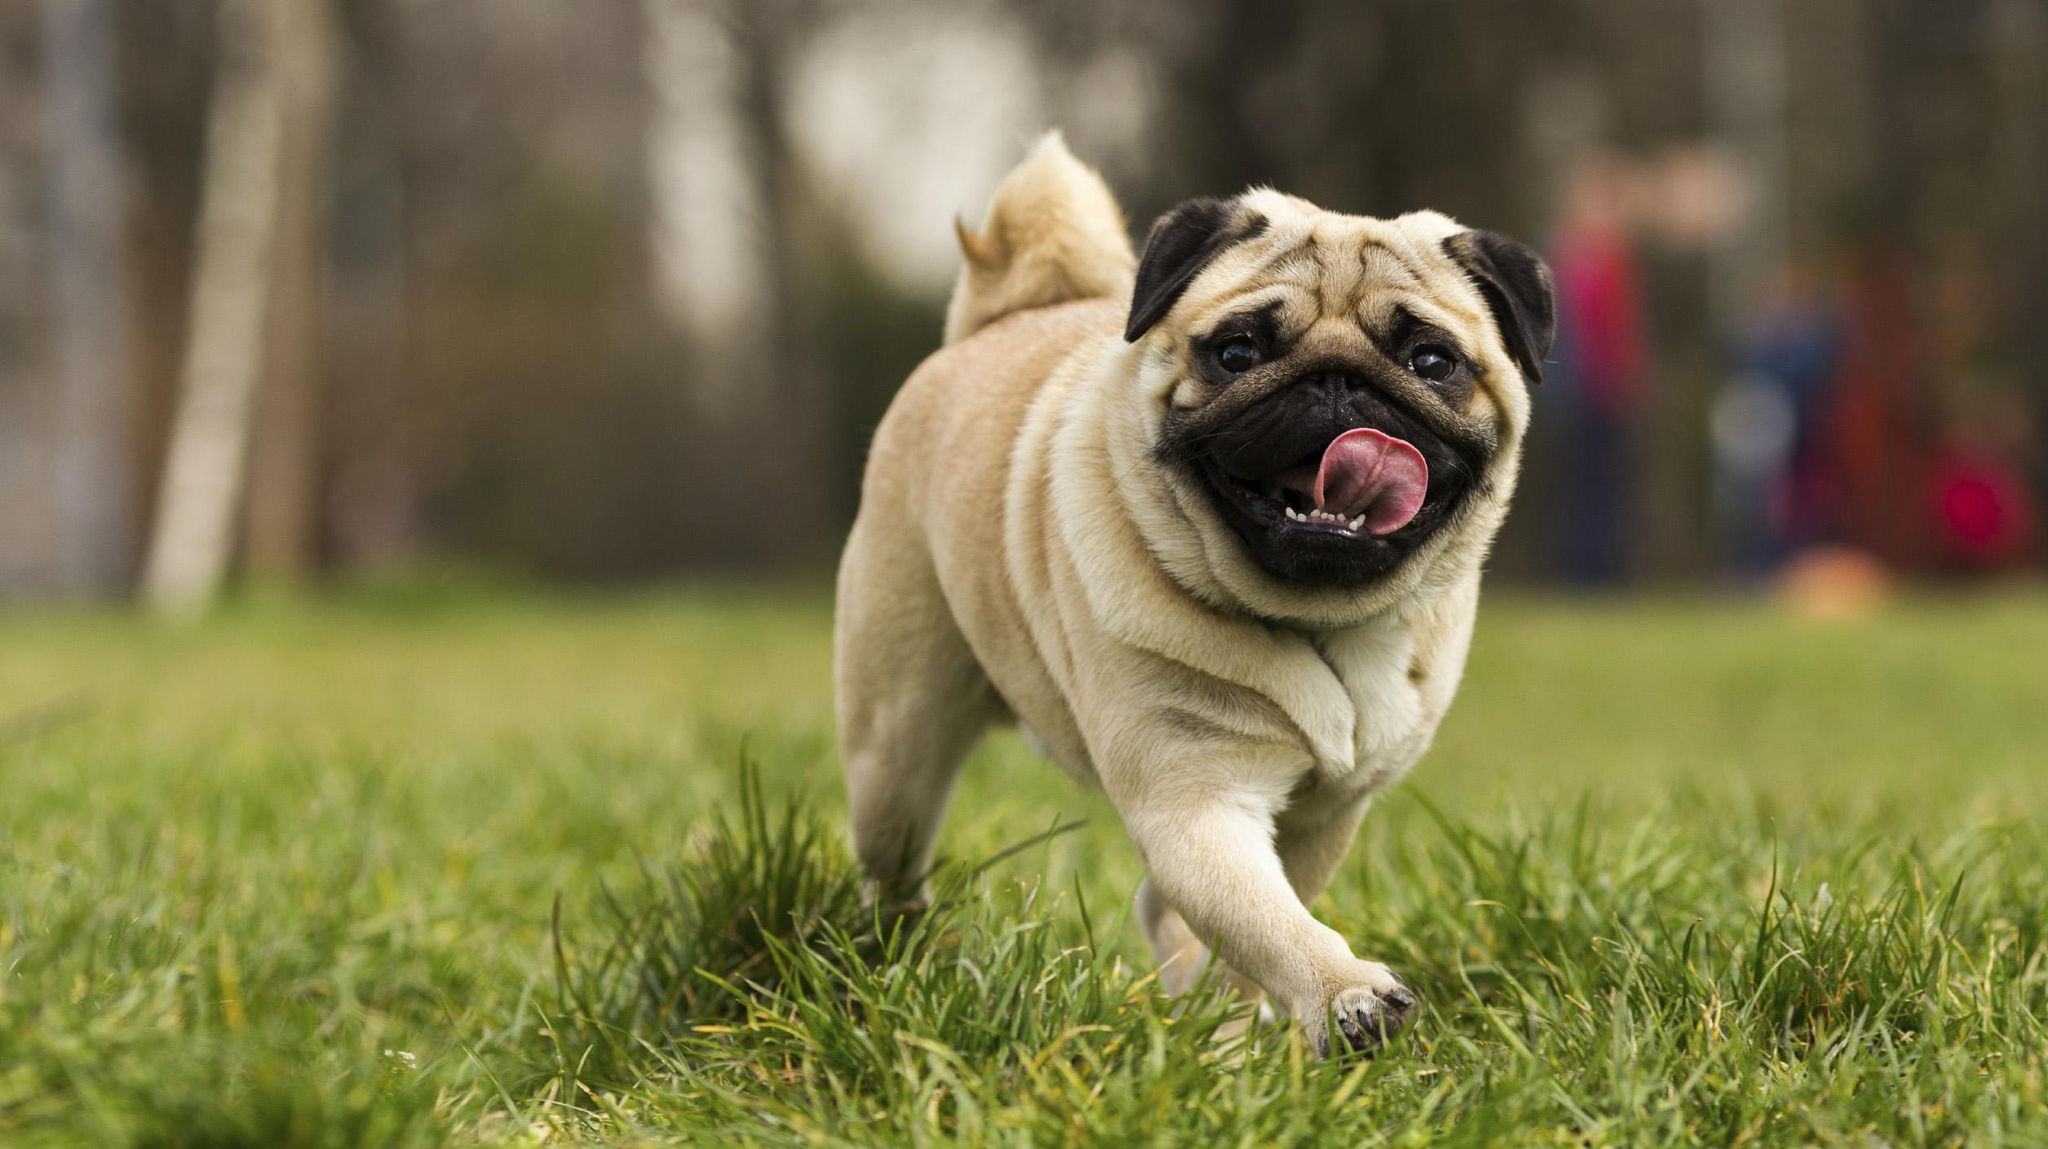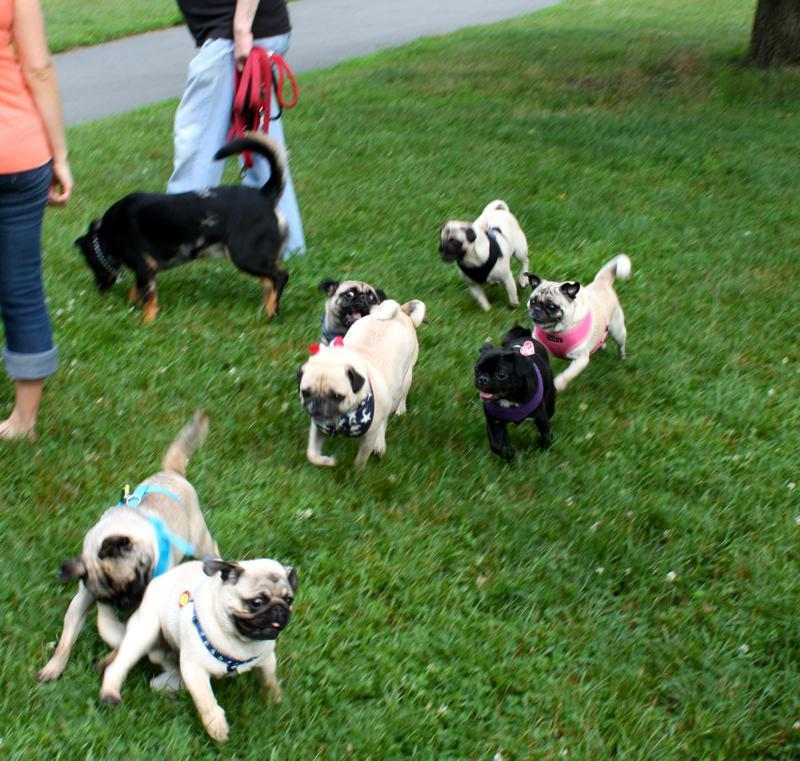The first image is the image on the left, the second image is the image on the right. Assess this claim about the two images: "There is at least one black pug running through the grass.". Correct or not? Answer yes or no. Yes. The first image is the image on the left, the second image is the image on the right. Considering the images on both sides, is "A white/beige colored pug has been caught on camera with his tongue out." valid? Answer yes or no. Yes. 